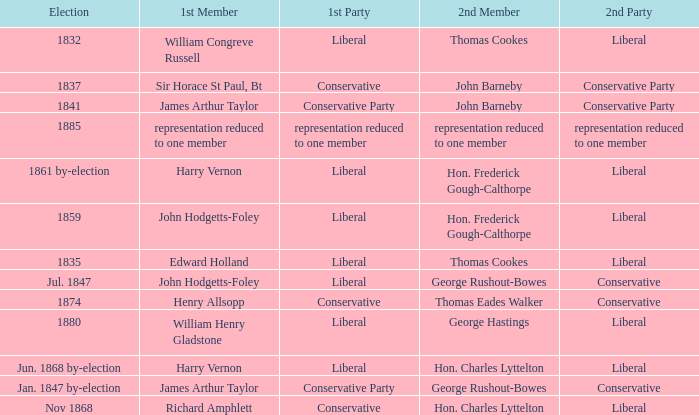What was the 1st Party when the 1st Member was William Congreve Russell? Liberal. 